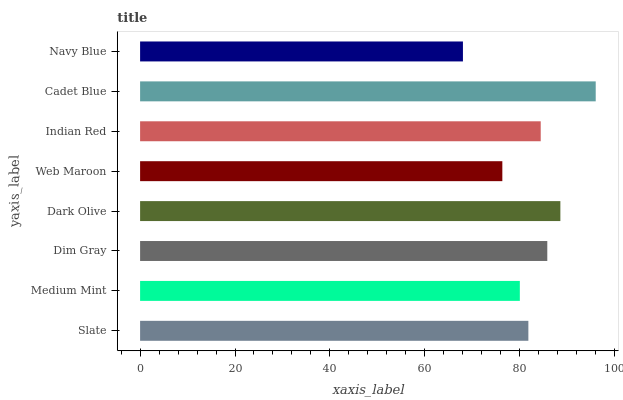Is Navy Blue the minimum?
Answer yes or no. Yes. Is Cadet Blue the maximum?
Answer yes or no. Yes. Is Medium Mint the minimum?
Answer yes or no. No. Is Medium Mint the maximum?
Answer yes or no. No. Is Slate greater than Medium Mint?
Answer yes or no. Yes. Is Medium Mint less than Slate?
Answer yes or no. Yes. Is Medium Mint greater than Slate?
Answer yes or no. No. Is Slate less than Medium Mint?
Answer yes or no. No. Is Indian Red the high median?
Answer yes or no. Yes. Is Slate the low median?
Answer yes or no. Yes. Is Dark Olive the high median?
Answer yes or no. No. Is Cadet Blue the low median?
Answer yes or no. No. 